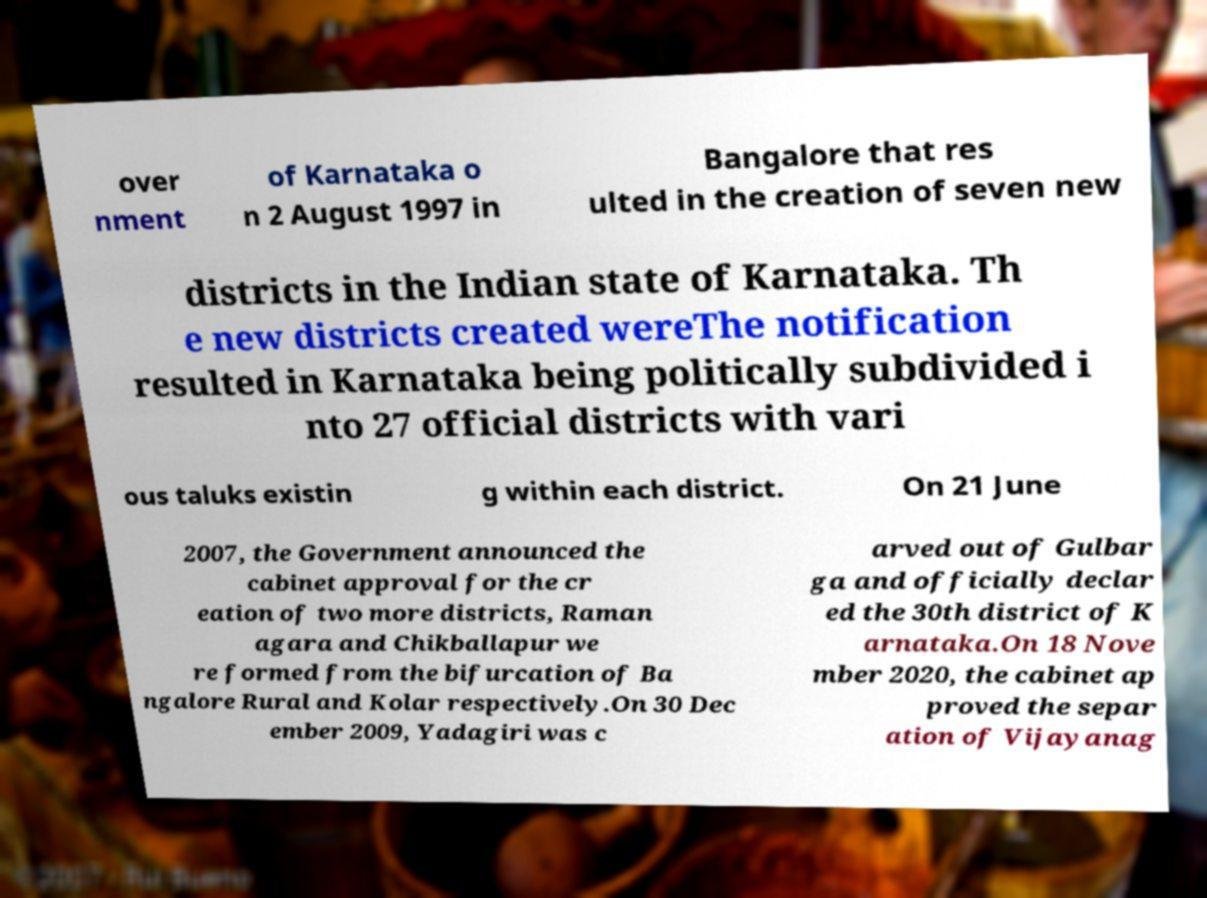Please read and relay the text visible in this image. What does it say? over nment of Karnataka o n 2 August 1997 in Bangalore that res ulted in the creation of seven new districts in the Indian state of Karnataka. Th e new districts created wereThe notification resulted in Karnataka being politically subdivided i nto 27 official districts with vari ous taluks existin g within each district. On 21 June 2007, the Government announced the cabinet approval for the cr eation of two more districts, Raman agara and Chikballapur we re formed from the bifurcation of Ba ngalore Rural and Kolar respectively.On 30 Dec ember 2009, Yadagiri was c arved out of Gulbar ga and officially declar ed the 30th district of K arnataka.On 18 Nove mber 2020, the cabinet ap proved the separ ation of Vijayanag 